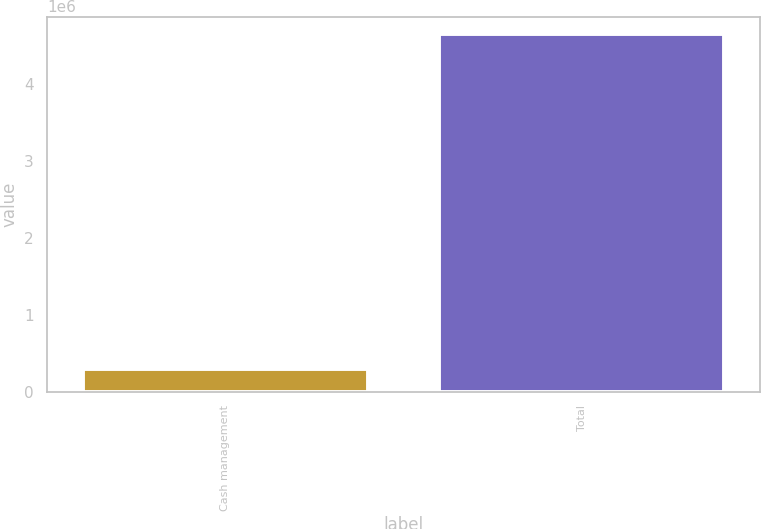Convert chart to OTSL. <chart><loc_0><loc_0><loc_500><loc_500><bar_chart><fcel>Cash management<fcel>Total<nl><fcel>299884<fcel>4.64541e+06<nl></chart> 